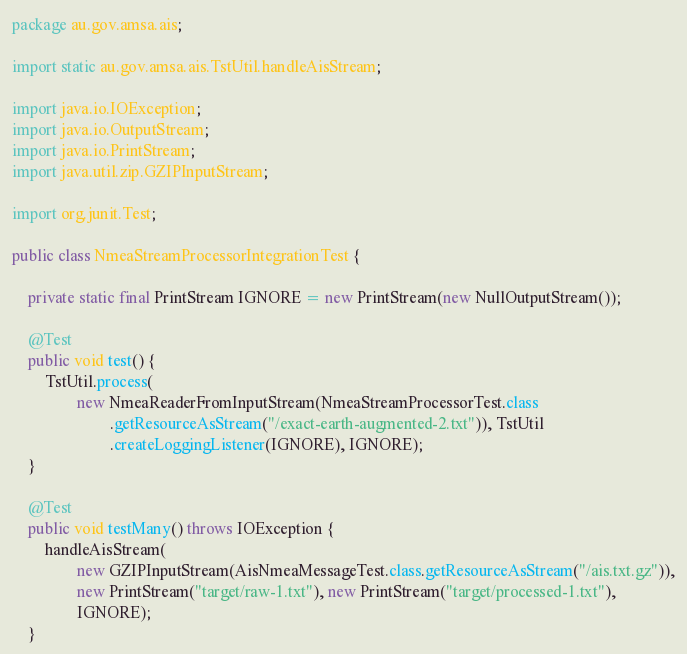<code> <loc_0><loc_0><loc_500><loc_500><_Java_>package au.gov.amsa.ais;

import static au.gov.amsa.ais.TstUtil.handleAisStream;

import java.io.IOException;
import java.io.OutputStream;
import java.io.PrintStream;
import java.util.zip.GZIPInputStream;

import org.junit.Test;

public class NmeaStreamProcessorIntegrationTest {

    private static final PrintStream IGNORE = new PrintStream(new NullOutputStream());

    @Test
    public void test() {
        TstUtil.process(
                new NmeaReaderFromInputStream(NmeaStreamProcessorTest.class
                        .getResourceAsStream("/exact-earth-augmented-2.txt")), TstUtil
                        .createLoggingListener(IGNORE), IGNORE);
    }

    @Test
    public void testMany() throws IOException {
        handleAisStream(
                new GZIPInputStream(AisNmeaMessageTest.class.getResourceAsStream("/ais.txt.gz")),
                new PrintStream("target/raw-1.txt"), new PrintStream("target/processed-1.txt"),
                IGNORE);
    }
</code> 